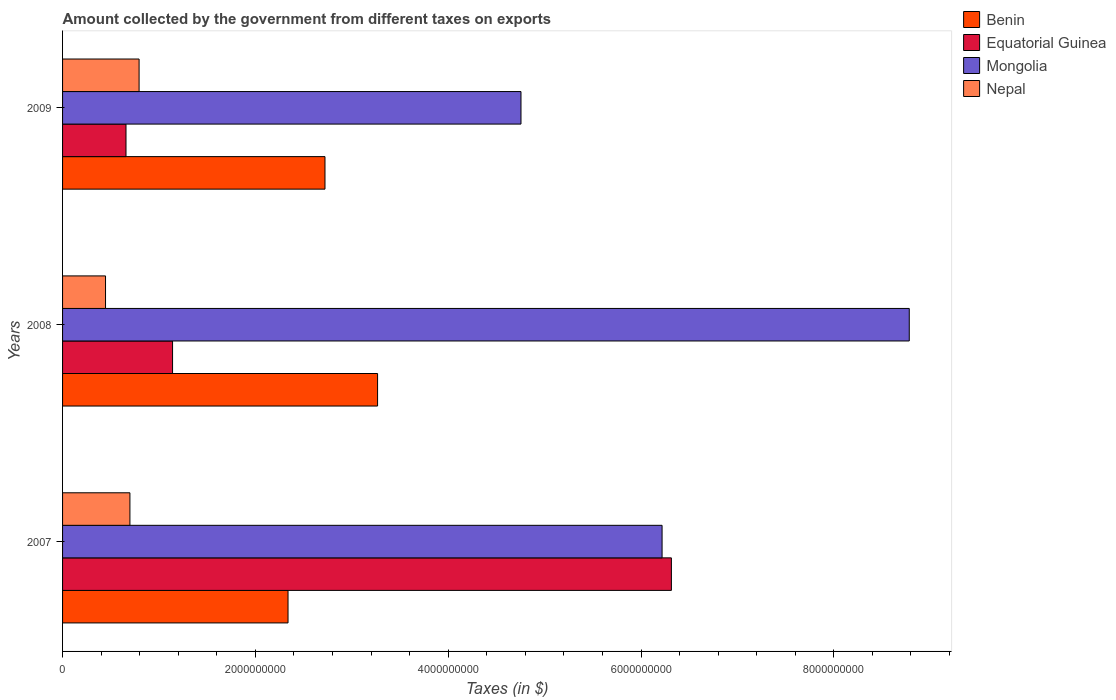Are the number of bars on each tick of the Y-axis equal?
Provide a short and direct response. Yes. How many bars are there on the 2nd tick from the top?
Your answer should be compact. 4. How many bars are there on the 1st tick from the bottom?
Your answer should be compact. 4. What is the label of the 2nd group of bars from the top?
Give a very brief answer. 2008. In how many cases, is the number of bars for a given year not equal to the number of legend labels?
Your response must be concise. 0. What is the amount collected by the government from taxes on exports in Nepal in 2009?
Ensure brevity in your answer.  7.94e+08. Across all years, what is the maximum amount collected by the government from taxes on exports in Mongolia?
Your response must be concise. 8.78e+09. Across all years, what is the minimum amount collected by the government from taxes on exports in Benin?
Make the answer very short. 2.34e+09. What is the total amount collected by the government from taxes on exports in Benin in the graph?
Your answer should be compact. 8.33e+09. What is the difference between the amount collected by the government from taxes on exports in Benin in 2007 and that in 2008?
Provide a succinct answer. -9.29e+08. What is the difference between the amount collected by the government from taxes on exports in Nepal in 2009 and the amount collected by the government from taxes on exports in Equatorial Guinea in 2008?
Provide a short and direct response. -3.47e+08. What is the average amount collected by the government from taxes on exports in Nepal per year?
Your answer should be very brief. 6.46e+08. In the year 2009, what is the difference between the amount collected by the government from taxes on exports in Mongolia and amount collected by the government from taxes on exports in Nepal?
Give a very brief answer. 3.96e+09. In how many years, is the amount collected by the government from taxes on exports in Benin greater than 8800000000 $?
Give a very brief answer. 0. What is the ratio of the amount collected by the government from taxes on exports in Equatorial Guinea in 2007 to that in 2008?
Give a very brief answer. 5.53. Is the amount collected by the government from taxes on exports in Nepal in 2007 less than that in 2008?
Ensure brevity in your answer.  No. What is the difference between the highest and the second highest amount collected by the government from taxes on exports in Nepal?
Ensure brevity in your answer.  9.52e+07. What is the difference between the highest and the lowest amount collected by the government from taxes on exports in Equatorial Guinea?
Make the answer very short. 5.66e+09. In how many years, is the amount collected by the government from taxes on exports in Nepal greater than the average amount collected by the government from taxes on exports in Nepal taken over all years?
Provide a short and direct response. 2. Is it the case that in every year, the sum of the amount collected by the government from taxes on exports in Nepal and amount collected by the government from taxes on exports in Benin is greater than the sum of amount collected by the government from taxes on exports in Equatorial Guinea and amount collected by the government from taxes on exports in Mongolia?
Provide a short and direct response. Yes. What does the 2nd bar from the top in 2007 represents?
Offer a terse response. Mongolia. What does the 3rd bar from the bottom in 2009 represents?
Your answer should be very brief. Mongolia. Is it the case that in every year, the sum of the amount collected by the government from taxes on exports in Nepal and amount collected by the government from taxes on exports in Mongolia is greater than the amount collected by the government from taxes on exports in Equatorial Guinea?
Your answer should be very brief. Yes. How many bars are there?
Your answer should be compact. 12. Are all the bars in the graph horizontal?
Provide a short and direct response. Yes. Are the values on the major ticks of X-axis written in scientific E-notation?
Make the answer very short. No. Where does the legend appear in the graph?
Offer a terse response. Top right. How many legend labels are there?
Ensure brevity in your answer.  4. How are the legend labels stacked?
Your answer should be very brief. Vertical. What is the title of the graph?
Provide a short and direct response. Amount collected by the government from different taxes on exports. Does "Ukraine" appear as one of the legend labels in the graph?
Your answer should be very brief. No. What is the label or title of the X-axis?
Offer a very short reply. Taxes (in $). What is the Taxes (in $) in Benin in 2007?
Offer a very short reply. 2.34e+09. What is the Taxes (in $) of Equatorial Guinea in 2007?
Make the answer very short. 6.32e+09. What is the Taxes (in $) in Mongolia in 2007?
Offer a very short reply. 6.22e+09. What is the Taxes (in $) of Nepal in 2007?
Make the answer very short. 6.99e+08. What is the Taxes (in $) in Benin in 2008?
Make the answer very short. 3.27e+09. What is the Taxes (in $) of Equatorial Guinea in 2008?
Offer a very short reply. 1.14e+09. What is the Taxes (in $) in Mongolia in 2008?
Give a very brief answer. 8.78e+09. What is the Taxes (in $) of Nepal in 2008?
Your answer should be very brief. 4.46e+08. What is the Taxes (in $) of Benin in 2009?
Give a very brief answer. 2.72e+09. What is the Taxes (in $) in Equatorial Guinea in 2009?
Your answer should be compact. 6.58e+08. What is the Taxes (in $) in Mongolia in 2009?
Your answer should be compact. 4.75e+09. What is the Taxes (in $) of Nepal in 2009?
Keep it short and to the point. 7.94e+08. Across all years, what is the maximum Taxes (in $) in Benin?
Your answer should be compact. 3.27e+09. Across all years, what is the maximum Taxes (in $) in Equatorial Guinea?
Your answer should be compact. 6.32e+09. Across all years, what is the maximum Taxes (in $) of Mongolia?
Your response must be concise. 8.78e+09. Across all years, what is the maximum Taxes (in $) of Nepal?
Make the answer very short. 7.94e+08. Across all years, what is the minimum Taxes (in $) in Benin?
Your answer should be very brief. 2.34e+09. Across all years, what is the minimum Taxes (in $) in Equatorial Guinea?
Give a very brief answer. 6.58e+08. Across all years, what is the minimum Taxes (in $) in Mongolia?
Offer a terse response. 4.75e+09. Across all years, what is the minimum Taxes (in $) in Nepal?
Offer a terse response. 4.46e+08. What is the total Taxes (in $) of Benin in the graph?
Offer a very short reply. 8.33e+09. What is the total Taxes (in $) in Equatorial Guinea in the graph?
Give a very brief answer. 8.11e+09. What is the total Taxes (in $) of Mongolia in the graph?
Ensure brevity in your answer.  1.98e+1. What is the total Taxes (in $) in Nepal in the graph?
Your response must be concise. 1.94e+09. What is the difference between the Taxes (in $) of Benin in 2007 and that in 2008?
Your answer should be very brief. -9.29e+08. What is the difference between the Taxes (in $) of Equatorial Guinea in 2007 and that in 2008?
Provide a succinct answer. 5.17e+09. What is the difference between the Taxes (in $) in Mongolia in 2007 and that in 2008?
Offer a terse response. -2.56e+09. What is the difference between the Taxes (in $) in Nepal in 2007 and that in 2008?
Provide a succinct answer. 2.53e+08. What is the difference between the Taxes (in $) in Benin in 2007 and that in 2009?
Offer a terse response. -3.83e+08. What is the difference between the Taxes (in $) of Equatorial Guinea in 2007 and that in 2009?
Give a very brief answer. 5.66e+09. What is the difference between the Taxes (in $) of Mongolia in 2007 and that in 2009?
Ensure brevity in your answer.  1.46e+09. What is the difference between the Taxes (in $) of Nepal in 2007 and that in 2009?
Make the answer very short. -9.52e+07. What is the difference between the Taxes (in $) of Benin in 2008 and that in 2009?
Offer a very short reply. 5.45e+08. What is the difference between the Taxes (in $) in Equatorial Guinea in 2008 and that in 2009?
Offer a terse response. 4.83e+08. What is the difference between the Taxes (in $) in Mongolia in 2008 and that in 2009?
Provide a short and direct response. 4.03e+09. What is the difference between the Taxes (in $) of Nepal in 2008 and that in 2009?
Provide a succinct answer. -3.48e+08. What is the difference between the Taxes (in $) of Benin in 2007 and the Taxes (in $) of Equatorial Guinea in 2008?
Your response must be concise. 1.20e+09. What is the difference between the Taxes (in $) in Benin in 2007 and the Taxes (in $) in Mongolia in 2008?
Your answer should be very brief. -6.44e+09. What is the difference between the Taxes (in $) in Benin in 2007 and the Taxes (in $) in Nepal in 2008?
Offer a terse response. 1.89e+09. What is the difference between the Taxes (in $) in Equatorial Guinea in 2007 and the Taxes (in $) in Mongolia in 2008?
Ensure brevity in your answer.  -2.47e+09. What is the difference between the Taxes (in $) of Equatorial Guinea in 2007 and the Taxes (in $) of Nepal in 2008?
Your answer should be very brief. 5.87e+09. What is the difference between the Taxes (in $) of Mongolia in 2007 and the Taxes (in $) of Nepal in 2008?
Provide a short and direct response. 5.77e+09. What is the difference between the Taxes (in $) of Benin in 2007 and the Taxes (in $) of Equatorial Guinea in 2009?
Offer a terse response. 1.68e+09. What is the difference between the Taxes (in $) of Benin in 2007 and the Taxes (in $) of Mongolia in 2009?
Offer a very short reply. -2.42e+09. What is the difference between the Taxes (in $) in Benin in 2007 and the Taxes (in $) in Nepal in 2009?
Offer a terse response. 1.54e+09. What is the difference between the Taxes (in $) in Equatorial Guinea in 2007 and the Taxes (in $) in Mongolia in 2009?
Your answer should be compact. 1.56e+09. What is the difference between the Taxes (in $) in Equatorial Guinea in 2007 and the Taxes (in $) in Nepal in 2009?
Keep it short and to the point. 5.52e+09. What is the difference between the Taxes (in $) in Mongolia in 2007 and the Taxes (in $) in Nepal in 2009?
Your response must be concise. 5.42e+09. What is the difference between the Taxes (in $) of Benin in 2008 and the Taxes (in $) of Equatorial Guinea in 2009?
Ensure brevity in your answer.  2.61e+09. What is the difference between the Taxes (in $) in Benin in 2008 and the Taxes (in $) in Mongolia in 2009?
Make the answer very short. -1.49e+09. What is the difference between the Taxes (in $) in Benin in 2008 and the Taxes (in $) in Nepal in 2009?
Your answer should be compact. 2.47e+09. What is the difference between the Taxes (in $) of Equatorial Guinea in 2008 and the Taxes (in $) of Mongolia in 2009?
Provide a succinct answer. -3.61e+09. What is the difference between the Taxes (in $) in Equatorial Guinea in 2008 and the Taxes (in $) in Nepal in 2009?
Ensure brevity in your answer.  3.47e+08. What is the difference between the Taxes (in $) in Mongolia in 2008 and the Taxes (in $) in Nepal in 2009?
Ensure brevity in your answer.  7.99e+09. What is the average Taxes (in $) in Benin per year?
Provide a succinct answer. 2.78e+09. What is the average Taxes (in $) in Equatorial Guinea per year?
Keep it short and to the point. 2.70e+09. What is the average Taxes (in $) of Mongolia per year?
Give a very brief answer. 6.59e+09. What is the average Taxes (in $) of Nepal per year?
Offer a terse response. 6.46e+08. In the year 2007, what is the difference between the Taxes (in $) in Benin and Taxes (in $) in Equatorial Guinea?
Keep it short and to the point. -3.98e+09. In the year 2007, what is the difference between the Taxes (in $) in Benin and Taxes (in $) in Mongolia?
Your response must be concise. -3.88e+09. In the year 2007, what is the difference between the Taxes (in $) in Benin and Taxes (in $) in Nepal?
Provide a succinct answer. 1.64e+09. In the year 2007, what is the difference between the Taxes (in $) in Equatorial Guinea and Taxes (in $) in Mongolia?
Keep it short and to the point. 9.66e+07. In the year 2007, what is the difference between the Taxes (in $) of Equatorial Guinea and Taxes (in $) of Nepal?
Your answer should be very brief. 5.62e+09. In the year 2007, what is the difference between the Taxes (in $) in Mongolia and Taxes (in $) in Nepal?
Keep it short and to the point. 5.52e+09. In the year 2008, what is the difference between the Taxes (in $) of Benin and Taxes (in $) of Equatorial Guinea?
Offer a very short reply. 2.13e+09. In the year 2008, what is the difference between the Taxes (in $) in Benin and Taxes (in $) in Mongolia?
Make the answer very short. -5.52e+09. In the year 2008, what is the difference between the Taxes (in $) of Benin and Taxes (in $) of Nepal?
Ensure brevity in your answer.  2.82e+09. In the year 2008, what is the difference between the Taxes (in $) of Equatorial Guinea and Taxes (in $) of Mongolia?
Provide a short and direct response. -7.64e+09. In the year 2008, what is the difference between the Taxes (in $) of Equatorial Guinea and Taxes (in $) of Nepal?
Offer a terse response. 6.95e+08. In the year 2008, what is the difference between the Taxes (in $) in Mongolia and Taxes (in $) in Nepal?
Make the answer very short. 8.34e+09. In the year 2009, what is the difference between the Taxes (in $) of Benin and Taxes (in $) of Equatorial Guinea?
Offer a very short reply. 2.06e+09. In the year 2009, what is the difference between the Taxes (in $) in Benin and Taxes (in $) in Mongolia?
Your answer should be compact. -2.03e+09. In the year 2009, what is the difference between the Taxes (in $) in Benin and Taxes (in $) in Nepal?
Give a very brief answer. 1.93e+09. In the year 2009, what is the difference between the Taxes (in $) of Equatorial Guinea and Taxes (in $) of Mongolia?
Provide a succinct answer. -4.10e+09. In the year 2009, what is the difference between the Taxes (in $) of Equatorial Guinea and Taxes (in $) of Nepal?
Keep it short and to the point. -1.36e+08. In the year 2009, what is the difference between the Taxes (in $) of Mongolia and Taxes (in $) of Nepal?
Provide a succinct answer. 3.96e+09. What is the ratio of the Taxes (in $) of Benin in 2007 to that in 2008?
Your response must be concise. 0.72. What is the ratio of the Taxes (in $) of Equatorial Guinea in 2007 to that in 2008?
Your response must be concise. 5.53. What is the ratio of the Taxes (in $) in Mongolia in 2007 to that in 2008?
Make the answer very short. 0.71. What is the ratio of the Taxes (in $) of Nepal in 2007 to that in 2008?
Provide a short and direct response. 1.57. What is the ratio of the Taxes (in $) of Benin in 2007 to that in 2009?
Make the answer very short. 0.86. What is the ratio of the Taxes (in $) in Equatorial Guinea in 2007 to that in 2009?
Your answer should be very brief. 9.6. What is the ratio of the Taxes (in $) in Mongolia in 2007 to that in 2009?
Your answer should be compact. 1.31. What is the ratio of the Taxes (in $) in Nepal in 2007 to that in 2009?
Provide a short and direct response. 0.88. What is the ratio of the Taxes (in $) of Benin in 2008 to that in 2009?
Your answer should be compact. 1.2. What is the ratio of the Taxes (in $) of Equatorial Guinea in 2008 to that in 2009?
Provide a short and direct response. 1.73. What is the ratio of the Taxes (in $) in Mongolia in 2008 to that in 2009?
Your answer should be very brief. 1.85. What is the ratio of the Taxes (in $) of Nepal in 2008 to that in 2009?
Your answer should be very brief. 0.56. What is the difference between the highest and the second highest Taxes (in $) of Benin?
Keep it short and to the point. 5.45e+08. What is the difference between the highest and the second highest Taxes (in $) in Equatorial Guinea?
Keep it short and to the point. 5.17e+09. What is the difference between the highest and the second highest Taxes (in $) of Mongolia?
Your answer should be very brief. 2.56e+09. What is the difference between the highest and the second highest Taxes (in $) of Nepal?
Your answer should be very brief. 9.52e+07. What is the difference between the highest and the lowest Taxes (in $) of Benin?
Offer a very short reply. 9.29e+08. What is the difference between the highest and the lowest Taxes (in $) in Equatorial Guinea?
Your response must be concise. 5.66e+09. What is the difference between the highest and the lowest Taxes (in $) in Mongolia?
Your answer should be very brief. 4.03e+09. What is the difference between the highest and the lowest Taxes (in $) of Nepal?
Ensure brevity in your answer.  3.48e+08. 